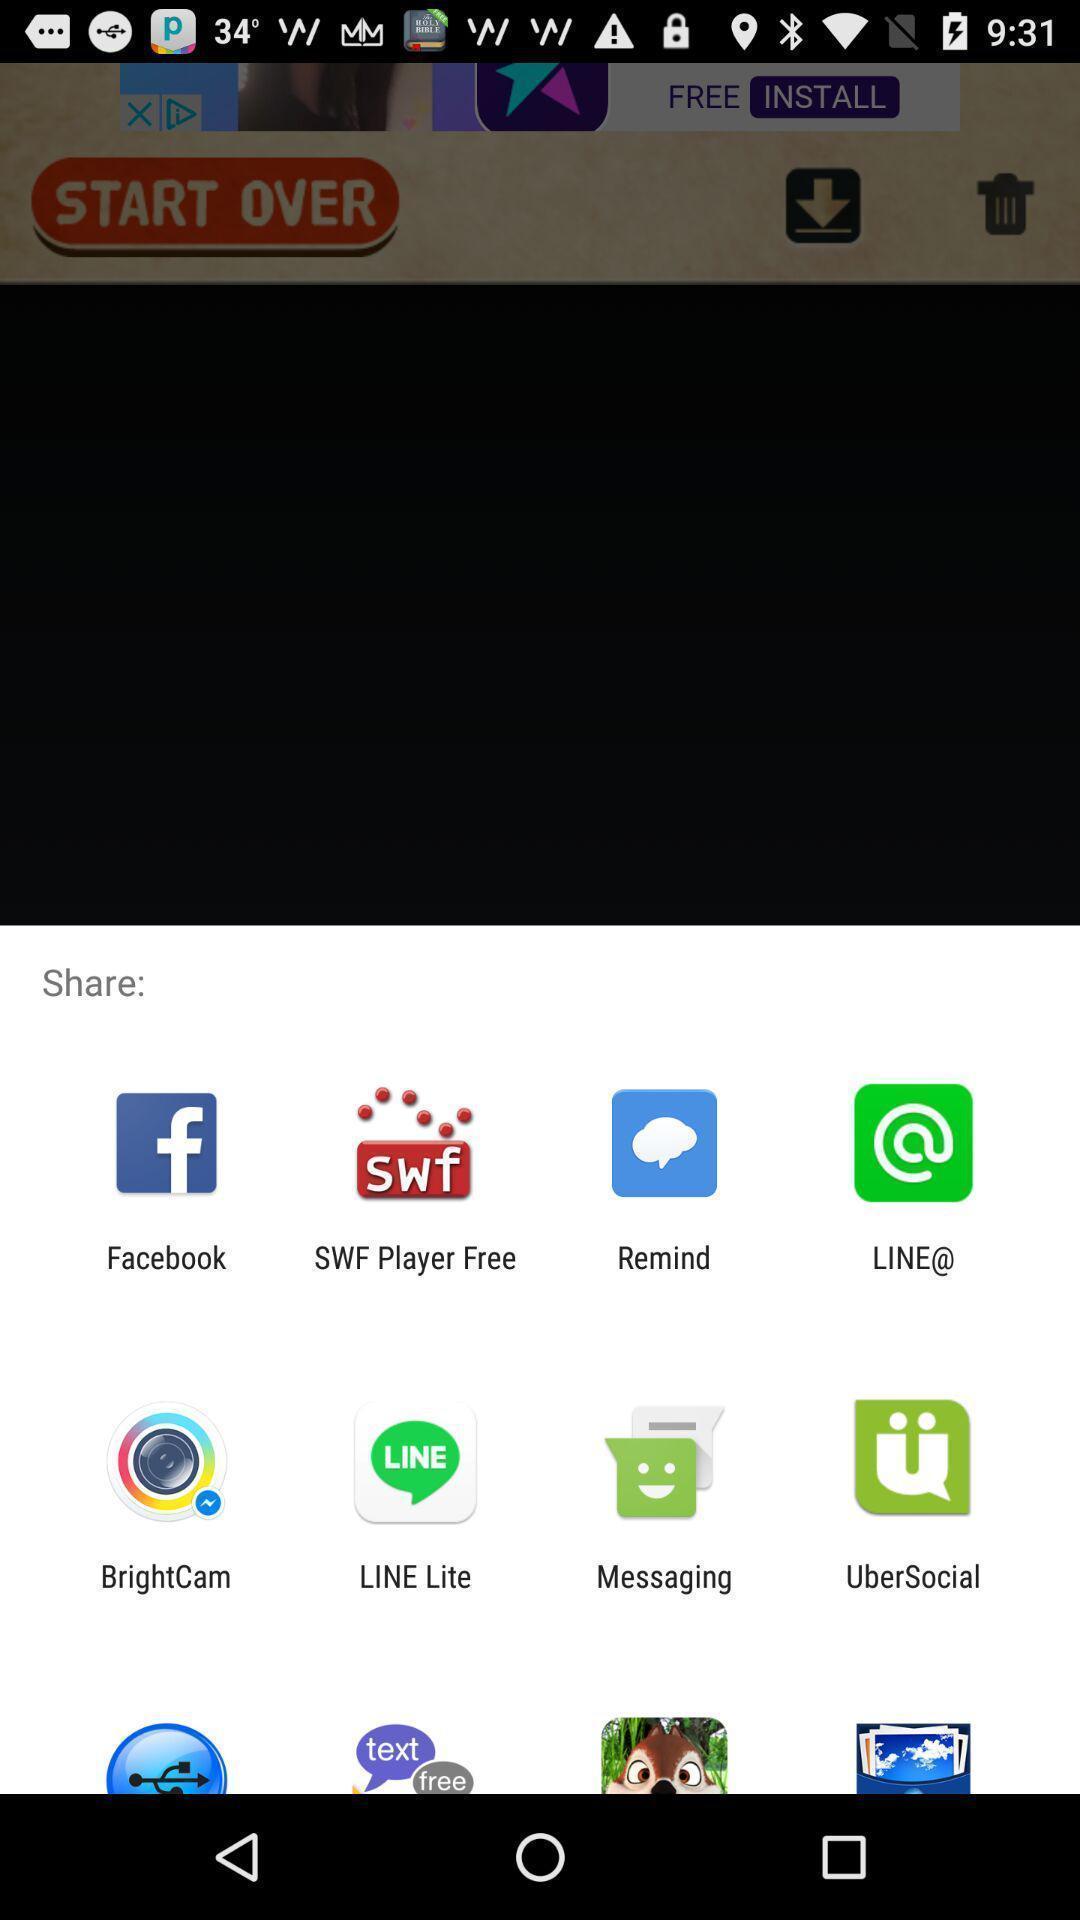Describe the content in this image. Pop-up with options for sharing content. 